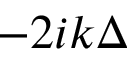<formula> <loc_0><loc_0><loc_500><loc_500>- 2 i k \Delta</formula> 